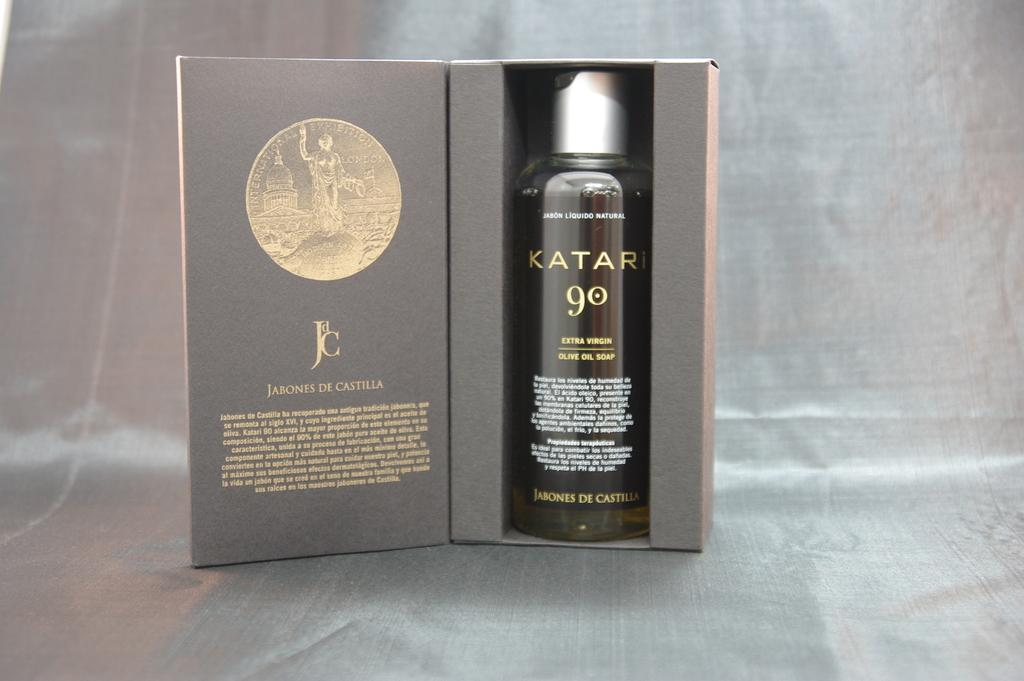<image>
Write a terse but informative summary of the picture. Bottle of Katari 90 inside an open box. 